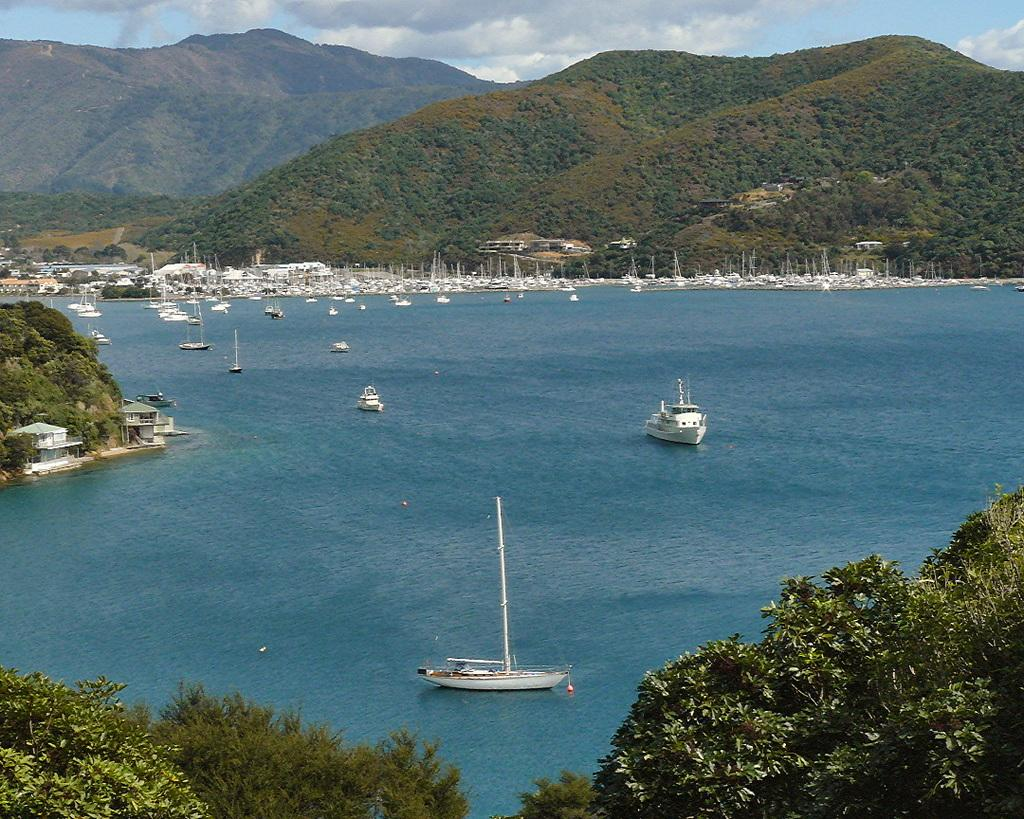What type of vehicles are in the image? There are boats in the image. What color are the boats? The boats are white. What is the primary setting in the image? There is water in the image. What can be seen in the background of the image? There are trees in the background of the image. What is the color of the trees? The trees are green. What is visible above the water and trees in the image? The sky is visible in the image. What colors can be seen in the sky? The sky has both white and blue colors. What type of punishment is being carried out in the image? There is no punishment being carried out in the image; it features boats on water with trees and a sky in the background. Is there any indication of death in the image? There is no indication of death in the image; it is a peaceful scene with boats on water and a natural environment. 